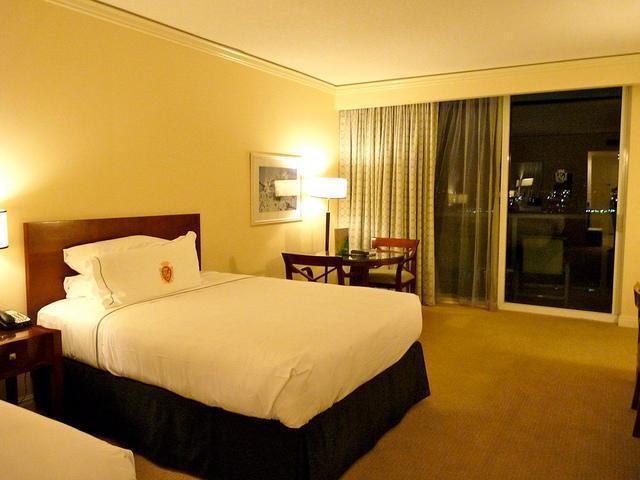How many beds in the room?
Give a very brief answer. 1. How many pillows are on the bed?
Give a very brief answer. 3. How many objects are hanging on the wall?
Give a very brief answer. 1. How many beds are there?
Give a very brief answer. 2. How many chairs can be seen?
Give a very brief answer. 2. 